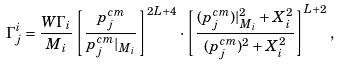Convert formula to latex. <formula><loc_0><loc_0><loc_500><loc_500>\Gamma ^ { i } _ { j } = \frac { W \Gamma _ { i } } { M _ { i } } \left [ \frac { p ^ { c m } _ { j } } { p ^ { c m } _ { j } | _ { M _ { i } } } \right ] ^ { 2 L + 4 } \cdot \left [ \frac { ( p ^ { c m } _ { j } ) | _ { M _ { i } } ^ { 2 } + X _ { i } ^ { 2 } } { ( p ^ { c m } _ { j } ) ^ { 2 } + X _ { i } ^ { 2 } } \right ] ^ { L + 2 } ,</formula> 